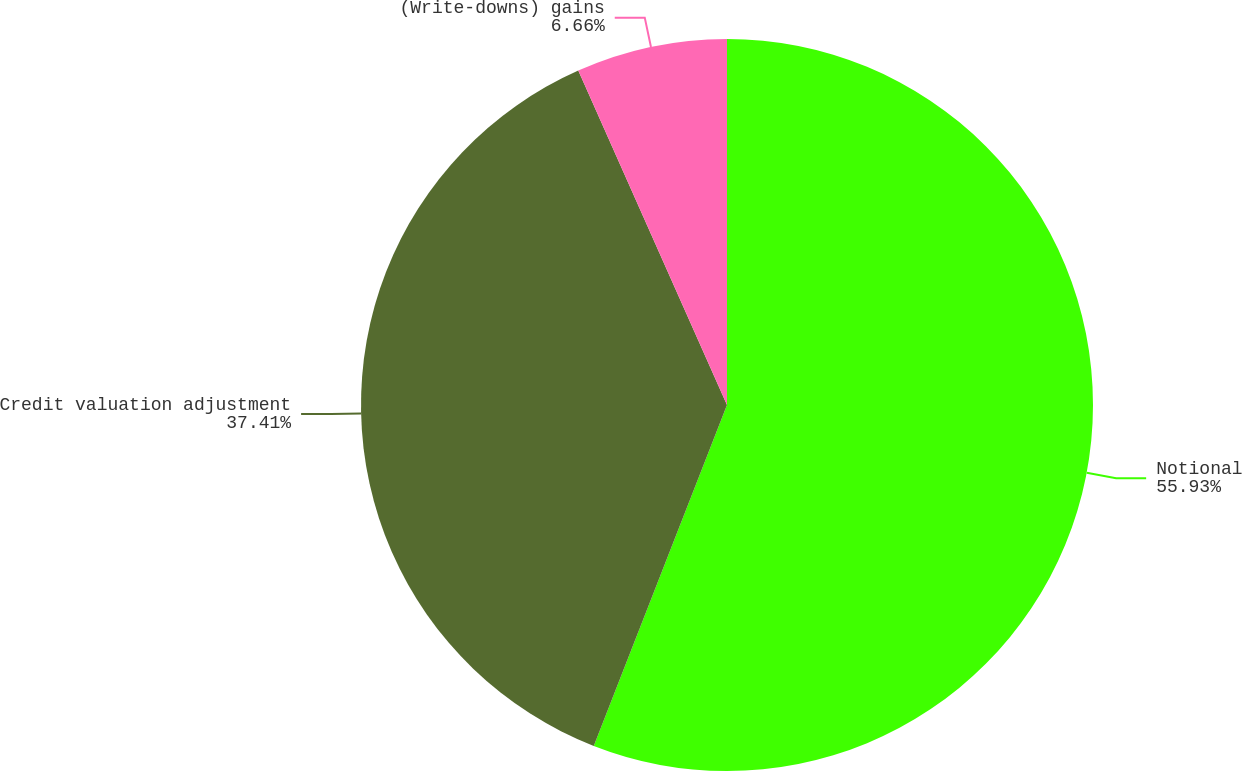Convert chart. <chart><loc_0><loc_0><loc_500><loc_500><pie_chart><fcel>Notional<fcel>Credit valuation adjustment<fcel>(Write-downs) gains<nl><fcel>55.93%<fcel>37.41%<fcel>6.66%<nl></chart> 